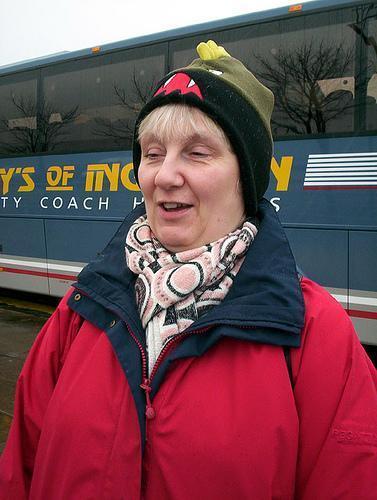How many people do you see?
Give a very brief answer. 1. 